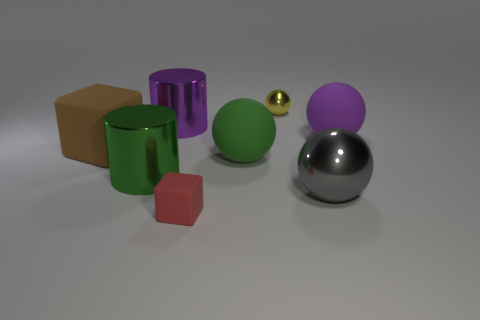Subtract all cyan balls. Subtract all purple blocks. How many balls are left? 4 Add 1 big cylinders. How many objects exist? 9 Subtract all blocks. How many objects are left? 6 Subtract 0 cyan cylinders. How many objects are left? 8 Subtract all big cubes. Subtract all large purple things. How many objects are left? 5 Add 1 small red blocks. How many small red blocks are left? 2 Add 7 yellow metallic spheres. How many yellow metallic spheres exist? 8 